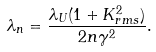<formula> <loc_0><loc_0><loc_500><loc_500>\lambda _ { n } = \frac { \lambda _ { U } ( 1 + K _ { r m s } ^ { 2 } ) } { 2 n \gamma ^ { 2 } } .</formula> 